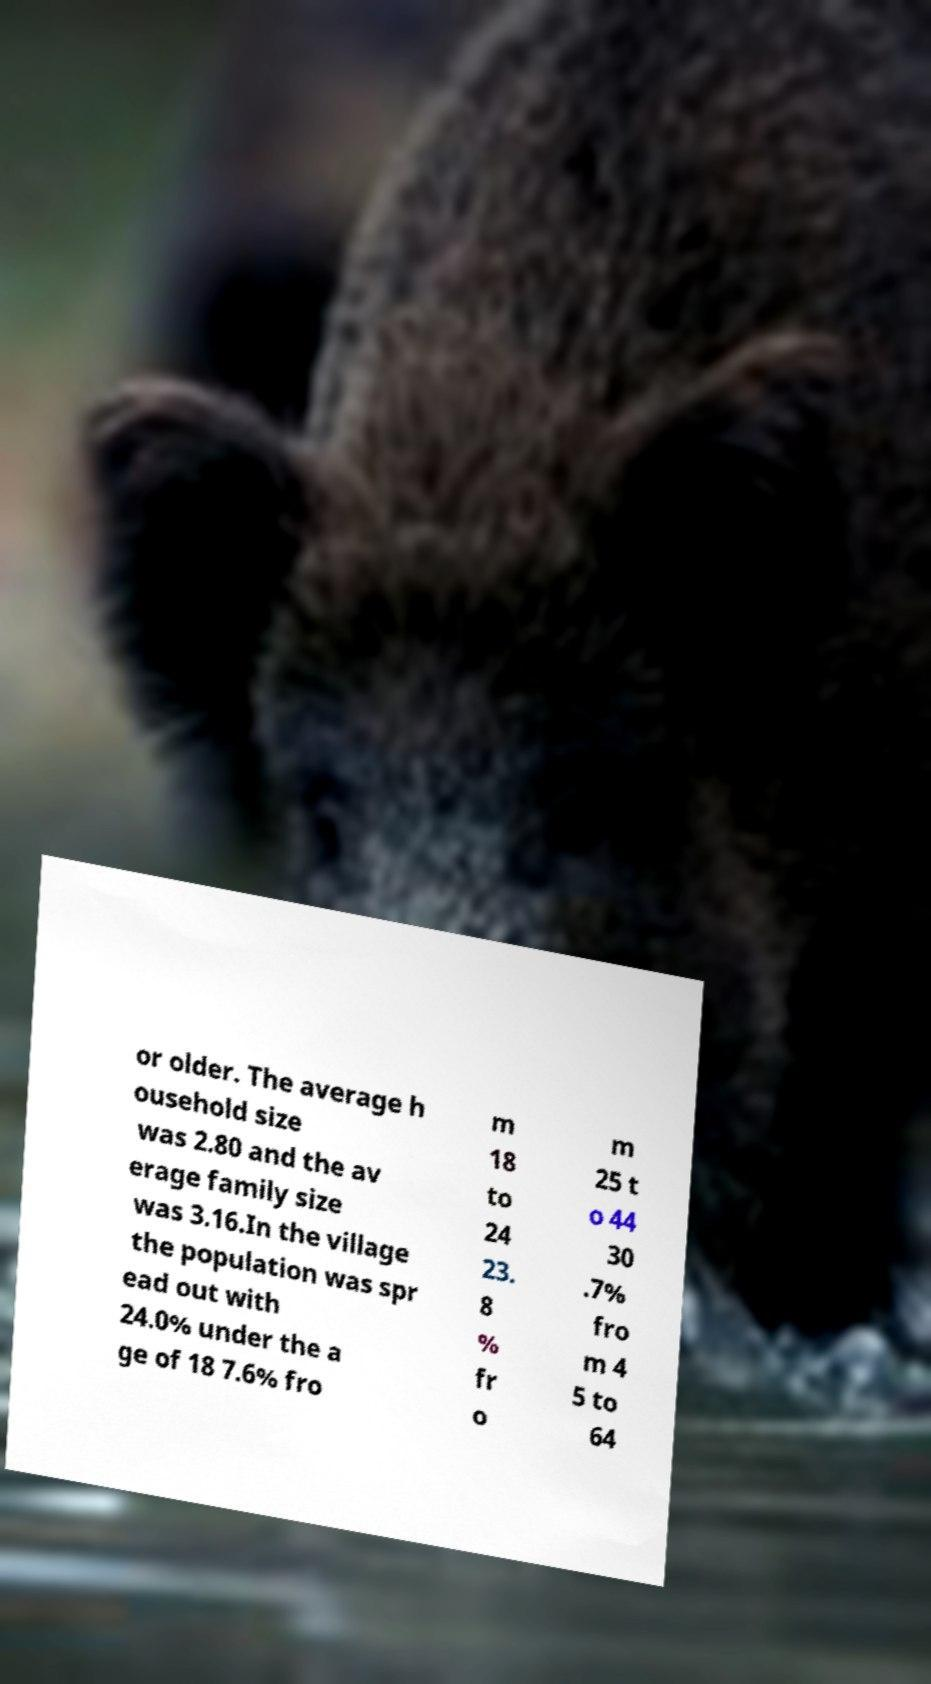I need the written content from this picture converted into text. Can you do that? or older. The average h ousehold size was 2.80 and the av erage family size was 3.16.In the village the population was spr ead out with 24.0% under the a ge of 18 7.6% fro m 18 to 24 23. 8 % fr o m 25 t o 44 30 .7% fro m 4 5 to 64 